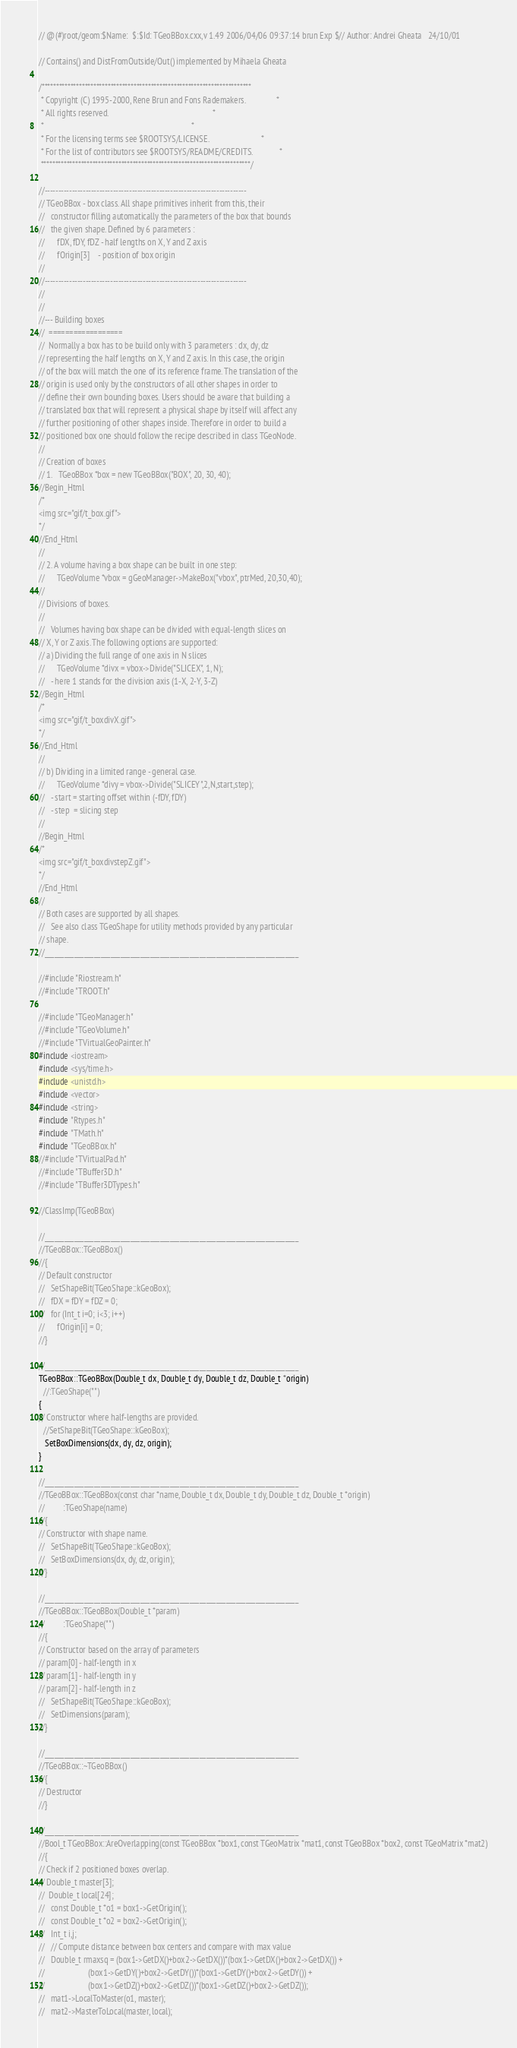<code> <loc_0><loc_0><loc_500><loc_500><_C++_>// @(#)root/geom:$Name:  $:$Id: TGeoBBox.cxx,v 1.49 2006/04/06 09:37:14 brun Exp $// Author: Andrei Gheata   24/10/01

// Contains() and DistFromOutside/Out() implemented by Mihaela Gheata

/*************************************************************************
 * Copyright (C) 1995-2000, Rene Brun and Fons Rademakers.               *
 * All rights reserved.                                                  *
 *                                                                       *
 * For the licensing terms see $ROOTSYS/LICENSE.                         *
 * For the list of contributors see $ROOTSYS/README/CREDITS.             *
 *************************************************************************/

//--------------------------------------------------------------------------
// TGeoBBox - box class. All shape primitives inherit from this, their 
//   constructor filling automatically the parameters of the box that bounds
//   the given shape. Defined by 6 parameters :
//      fDX, fDY, fDZ - half lengths on X, Y and Z axis
//      fOrigin[3]    - position of box origin
//
//--------------------------------------------------------------------------
//
//
//--- Building boxes
//  ==================
//  Normally a box has to be build only with 3 parameters : dx, dy, dz
// representing the half lengths on X, Y and Z axis. In this case, the origin 
// of the box will match the one of its reference frame. The translation of the
// origin is used only by the constructors of all other shapes in order to
// define their own bounding boxes. Users should be aware that building a
// translated box that will represent a physical shape by itself will affect any
// further positioning of other shapes inside. Therefore in order to build a
// positioned box one should follow the recipe described in class TGeoNode.
//
// Creation of boxes
// 1.   TGeoBBox *box = new TGeoBBox("BOX", 20, 30, 40);
//Begin_Html
/*
<img src="gif/t_box.gif">
*/
//End_Html
//
// 2. A volume having a box shape can be built in one step:
//      TGeoVolume *vbox = gGeoManager->MakeBox("vbox", ptrMed, 20,30,40);
//
// Divisions of boxes.
//
//   Volumes having box shape can be divided with equal-length slices on 
// X, Y or Z axis. The following options are supported:
// a) Dividing the full range of one axis in N slices
//      TGeoVolume *divx = vbox->Divide("SLICEX", 1, N);
//   - here 1 stands for the division axis (1-X, 2-Y, 3-Z)
//Begin_Html
/*
<img src="gif/t_boxdivX.gif">
*/
//End_Html
//
// b) Dividing in a limited range - general case.
//      TGeoVolume *divy = vbox->Divide("SLICEY",2,N,start,step);
//   - start = starting offset within (-fDY, fDY)
//   - step  = slicing step
//
//Begin_Html
/*
<img src="gif/t_boxdivstepZ.gif">
*/
//End_Html
//
// Both cases are supported by all shapes.
//   See also class TGeoShape for utility methods provided by any particular 
// shape.
//_____________________________________________________________________________

//#include "Riostream.h"
//#include "TROOT.h"

//#include "TGeoManager.h"
//#include "TGeoVolume.h"
//#include "TVirtualGeoPainter.h"
#include <iostream>
#include <sys/time.h>
#include <unistd.h>
#include <vector>
#include <string>
#include "Rtypes.h"
#include "TMath.h"
#include "TGeoBBox.h"
//#include "TVirtualPad.h"
//#include "TBuffer3D.h"
//#include "TBuffer3DTypes.h"

//ClassImp(TGeoBBox)
   
//_____________________________________________________________________________
//TGeoBBox::TGeoBBox()
//{
// Default constructor
//   SetShapeBit(TGeoShape::kGeoBox);
//   fDX = fDY = fDZ = 0;
//   for (Int_t i=0; i<3; i++)
//      fOrigin[i] = 0;
//}   

//_____________________________________________________________________________
TGeoBBox::TGeoBBox(Double_t dx, Double_t dy, Double_t dz, Double_t *origin)
  //:TGeoShape("")
{
// Constructor where half-lengths are provided.
  //SetShapeBit(TGeoShape::kGeoBox);
   SetBoxDimensions(dx, dy, dz, origin);
}

//_____________________________________________________________________________
//TGeoBBox::TGeoBBox(const char *name, Double_t dx, Double_t dy, Double_t dz, Double_t *origin)
//         :TGeoShape(name)
//{
// Constructor with shape name.
//   SetShapeBit(TGeoShape::kGeoBox);
//   SetBoxDimensions(dx, dy, dz, origin);
//}

//_____________________________________________________________________________
//TGeoBBox::TGeoBBox(Double_t *param)
//         :TGeoShape("")
//{
// Constructor based on the array of parameters
// param[0] - half-length in x
// param[1] - half-length in y
// param[2] - half-length in z
//   SetShapeBit(TGeoShape::kGeoBox);
//   SetDimensions(param);
//}   

//_____________________________________________________________________________
//TGeoBBox::~TGeoBBox()
//{
// Destructor
//}

//_____________________________________________________________________________
//Bool_t TGeoBBox::AreOverlapping(const TGeoBBox *box1, const TGeoMatrix *mat1, const TGeoBBox *box2, const TGeoMatrix *mat2)
//{
// Check if 2 positioned boxes overlap.
// Double_t master[3];
//  Double_t local[24];
//   const Double_t *o1 = box1->GetOrigin();
//   const Double_t *o2 = box2->GetOrigin();
//   Int_t i,j;
//   // Compute distance between box centers and compare with max value
//   Double_t rmaxsq = (box1->GetDX()+box2->GetDX())*(box1->GetDX()+box2->GetDX()) +
//                     (box1->GetDY()+box2->GetDY())*(box1->GetDY()+box2->GetDY()) +
//                     (box1->GetDZ()+box2->GetDZ())*(box1->GetDZ()+box2->GetDZ());
//   mat1->LocalToMaster(o1, master);
//   mat2->MasterToLocal(master, local);</code> 